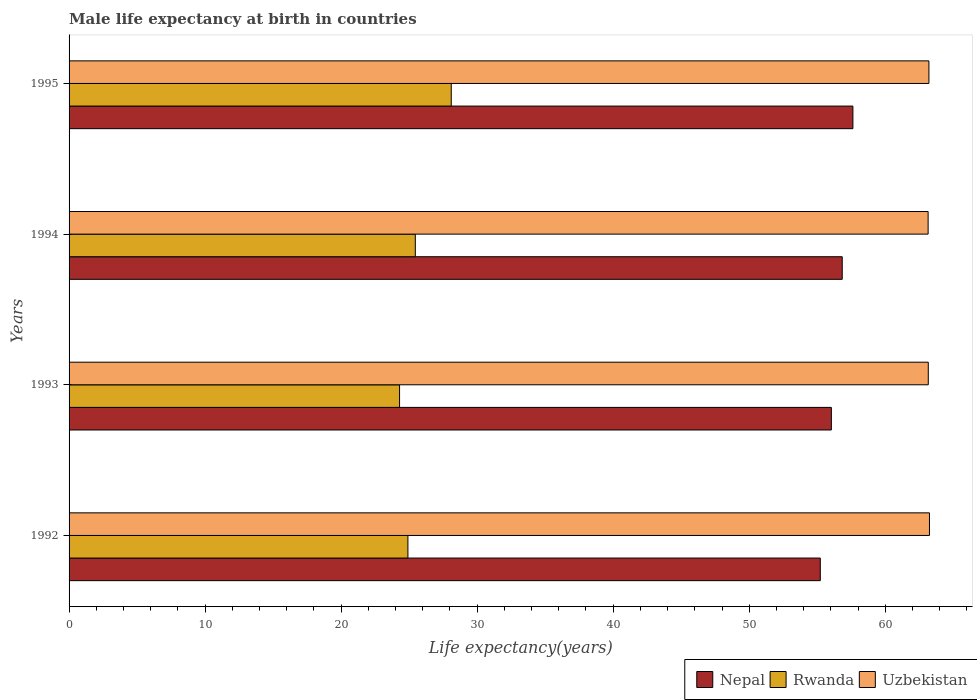Are the number of bars per tick equal to the number of legend labels?
Provide a succinct answer. Yes. In how many cases, is the number of bars for a given year not equal to the number of legend labels?
Provide a short and direct response. 0. What is the male life expectancy at birth in Uzbekistan in 1995?
Ensure brevity in your answer.  63.21. Across all years, what is the maximum male life expectancy at birth in Rwanda?
Your answer should be compact. 28.09. Across all years, what is the minimum male life expectancy at birth in Uzbekistan?
Provide a succinct answer. 63.15. In which year was the male life expectancy at birth in Nepal maximum?
Offer a terse response. 1995. What is the total male life expectancy at birth in Nepal in the graph?
Offer a terse response. 225.72. What is the difference between the male life expectancy at birth in Nepal in 1992 and that in 1995?
Offer a very short reply. -2.4. What is the difference between the male life expectancy at birth in Uzbekistan in 1993 and the male life expectancy at birth in Rwanda in 1992?
Provide a succinct answer. 38.25. What is the average male life expectancy at birth in Rwanda per year?
Make the answer very short. 25.69. In the year 1995, what is the difference between the male life expectancy at birth in Nepal and male life expectancy at birth in Rwanda?
Your answer should be very brief. 29.53. In how many years, is the male life expectancy at birth in Nepal greater than 26 years?
Give a very brief answer. 4. What is the ratio of the male life expectancy at birth in Rwanda in 1992 to that in 1994?
Your response must be concise. 0.98. What is the difference between the highest and the second highest male life expectancy at birth in Rwanda?
Your answer should be compact. 2.64. What is the difference between the highest and the lowest male life expectancy at birth in Nepal?
Your answer should be very brief. 2.4. In how many years, is the male life expectancy at birth in Rwanda greater than the average male life expectancy at birth in Rwanda taken over all years?
Provide a succinct answer. 1. What does the 2nd bar from the top in 1995 represents?
Provide a succinct answer. Rwanda. What does the 3rd bar from the bottom in 1992 represents?
Your response must be concise. Uzbekistan. How many bars are there?
Offer a terse response. 12. Are all the bars in the graph horizontal?
Your answer should be compact. Yes. How many years are there in the graph?
Offer a terse response. 4. What is the difference between two consecutive major ticks on the X-axis?
Your answer should be compact. 10. Are the values on the major ticks of X-axis written in scientific E-notation?
Provide a succinct answer. No. Does the graph contain any zero values?
Keep it short and to the point. No. Does the graph contain grids?
Offer a terse response. No. How many legend labels are there?
Your response must be concise. 3. What is the title of the graph?
Ensure brevity in your answer.  Male life expectancy at birth in countries. Does "Bahamas" appear as one of the legend labels in the graph?
Give a very brief answer. No. What is the label or title of the X-axis?
Make the answer very short. Life expectancy(years). What is the Life expectancy(years) of Nepal in 1992?
Your answer should be compact. 55.22. What is the Life expectancy(years) in Rwanda in 1992?
Provide a short and direct response. 24.91. What is the Life expectancy(years) of Uzbekistan in 1992?
Your answer should be very brief. 63.25. What is the Life expectancy(years) of Nepal in 1993?
Provide a short and direct response. 56.04. What is the Life expectancy(years) of Rwanda in 1993?
Keep it short and to the point. 24.3. What is the Life expectancy(years) in Uzbekistan in 1993?
Ensure brevity in your answer.  63.16. What is the Life expectancy(years) of Nepal in 1994?
Give a very brief answer. 56.84. What is the Life expectancy(years) of Rwanda in 1994?
Offer a terse response. 25.45. What is the Life expectancy(years) in Uzbekistan in 1994?
Keep it short and to the point. 63.15. What is the Life expectancy(years) of Nepal in 1995?
Your response must be concise. 57.62. What is the Life expectancy(years) of Rwanda in 1995?
Provide a short and direct response. 28.09. What is the Life expectancy(years) in Uzbekistan in 1995?
Provide a short and direct response. 63.21. Across all years, what is the maximum Life expectancy(years) in Nepal?
Offer a very short reply. 57.62. Across all years, what is the maximum Life expectancy(years) of Rwanda?
Offer a very short reply. 28.09. Across all years, what is the maximum Life expectancy(years) in Uzbekistan?
Provide a short and direct response. 63.25. Across all years, what is the minimum Life expectancy(years) of Nepal?
Give a very brief answer. 55.22. Across all years, what is the minimum Life expectancy(years) of Rwanda?
Provide a succinct answer. 24.3. Across all years, what is the minimum Life expectancy(years) in Uzbekistan?
Your answer should be very brief. 63.15. What is the total Life expectancy(years) in Nepal in the graph?
Your response must be concise. 225.72. What is the total Life expectancy(years) in Rwanda in the graph?
Make the answer very short. 102.75. What is the total Life expectancy(years) in Uzbekistan in the graph?
Your answer should be very brief. 252.77. What is the difference between the Life expectancy(years) of Nepal in 1992 and that in 1993?
Offer a very short reply. -0.81. What is the difference between the Life expectancy(years) of Rwanda in 1992 and that in 1993?
Your answer should be compact. 0.61. What is the difference between the Life expectancy(years) of Uzbekistan in 1992 and that in 1993?
Ensure brevity in your answer.  0.09. What is the difference between the Life expectancy(years) in Nepal in 1992 and that in 1994?
Give a very brief answer. -1.61. What is the difference between the Life expectancy(years) in Rwanda in 1992 and that in 1994?
Provide a succinct answer. -0.54. What is the difference between the Life expectancy(years) of Uzbekistan in 1992 and that in 1994?
Provide a short and direct response. 0.1. What is the difference between the Life expectancy(years) of Nepal in 1992 and that in 1995?
Ensure brevity in your answer.  -2.4. What is the difference between the Life expectancy(years) of Rwanda in 1992 and that in 1995?
Keep it short and to the point. -3.19. What is the difference between the Life expectancy(years) in Nepal in 1993 and that in 1994?
Your response must be concise. -0.8. What is the difference between the Life expectancy(years) of Rwanda in 1993 and that in 1994?
Keep it short and to the point. -1.16. What is the difference between the Life expectancy(years) of Uzbekistan in 1993 and that in 1994?
Keep it short and to the point. 0.01. What is the difference between the Life expectancy(years) in Nepal in 1993 and that in 1995?
Your response must be concise. -1.58. What is the difference between the Life expectancy(years) in Uzbekistan in 1993 and that in 1995?
Provide a short and direct response. -0.05. What is the difference between the Life expectancy(years) in Nepal in 1994 and that in 1995?
Make the answer very short. -0.78. What is the difference between the Life expectancy(years) of Rwanda in 1994 and that in 1995?
Offer a very short reply. -2.64. What is the difference between the Life expectancy(years) in Uzbekistan in 1994 and that in 1995?
Offer a very short reply. -0.06. What is the difference between the Life expectancy(years) of Nepal in 1992 and the Life expectancy(years) of Rwanda in 1993?
Provide a succinct answer. 30.93. What is the difference between the Life expectancy(years) of Nepal in 1992 and the Life expectancy(years) of Uzbekistan in 1993?
Offer a terse response. -7.94. What is the difference between the Life expectancy(years) in Rwanda in 1992 and the Life expectancy(years) in Uzbekistan in 1993?
Keep it short and to the point. -38.25. What is the difference between the Life expectancy(years) of Nepal in 1992 and the Life expectancy(years) of Rwanda in 1994?
Offer a terse response. 29.77. What is the difference between the Life expectancy(years) in Nepal in 1992 and the Life expectancy(years) in Uzbekistan in 1994?
Your response must be concise. -7.93. What is the difference between the Life expectancy(years) of Rwanda in 1992 and the Life expectancy(years) of Uzbekistan in 1994?
Offer a very short reply. -38.24. What is the difference between the Life expectancy(years) of Nepal in 1992 and the Life expectancy(years) of Rwanda in 1995?
Offer a terse response. 27.13. What is the difference between the Life expectancy(years) of Nepal in 1992 and the Life expectancy(years) of Uzbekistan in 1995?
Your response must be concise. -7.99. What is the difference between the Life expectancy(years) of Rwanda in 1992 and the Life expectancy(years) of Uzbekistan in 1995?
Your response must be concise. -38.3. What is the difference between the Life expectancy(years) of Nepal in 1993 and the Life expectancy(years) of Rwanda in 1994?
Give a very brief answer. 30.58. What is the difference between the Life expectancy(years) of Nepal in 1993 and the Life expectancy(years) of Uzbekistan in 1994?
Ensure brevity in your answer.  -7.11. What is the difference between the Life expectancy(years) of Rwanda in 1993 and the Life expectancy(years) of Uzbekistan in 1994?
Your response must be concise. -38.86. What is the difference between the Life expectancy(years) in Nepal in 1993 and the Life expectancy(years) in Rwanda in 1995?
Give a very brief answer. 27.94. What is the difference between the Life expectancy(years) of Nepal in 1993 and the Life expectancy(years) of Uzbekistan in 1995?
Your answer should be compact. -7.17. What is the difference between the Life expectancy(years) in Rwanda in 1993 and the Life expectancy(years) in Uzbekistan in 1995?
Your answer should be compact. -38.91. What is the difference between the Life expectancy(years) in Nepal in 1994 and the Life expectancy(years) in Rwanda in 1995?
Give a very brief answer. 28.74. What is the difference between the Life expectancy(years) of Nepal in 1994 and the Life expectancy(years) of Uzbekistan in 1995?
Keep it short and to the point. -6.37. What is the difference between the Life expectancy(years) in Rwanda in 1994 and the Life expectancy(years) in Uzbekistan in 1995?
Provide a succinct answer. -37.76. What is the average Life expectancy(years) of Nepal per year?
Offer a terse response. 56.43. What is the average Life expectancy(years) of Rwanda per year?
Provide a succinct answer. 25.69. What is the average Life expectancy(years) in Uzbekistan per year?
Make the answer very short. 63.19. In the year 1992, what is the difference between the Life expectancy(years) of Nepal and Life expectancy(years) of Rwanda?
Make the answer very short. 30.31. In the year 1992, what is the difference between the Life expectancy(years) of Nepal and Life expectancy(years) of Uzbekistan?
Ensure brevity in your answer.  -8.03. In the year 1992, what is the difference between the Life expectancy(years) of Rwanda and Life expectancy(years) of Uzbekistan?
Keep it short and to the point. -38.34. In the year 1993, what is the difference between the Life expectancy(years) of Nepal and Life expectancy(years) of Rwanda?
Offer a terse response. 31.74. In the year 1993, what is the difference between the Life expectancy(years) of Nepal and Life expectancy(years) of Uzbekistan?
Provide a succinct answer. -7.13. In the year 1993, what is the difference between the Life expectancy(years) in Rwanda and Life expectancy(years) in Uzbekistan?
Ensure brevity in your answer.  -38.87. In the year 1994, what is the difference between the Life expectancy(years) in Nepal and Life expectancy(years) in Rwanda?
Offer a very short reply. 31.38. In the year 1994, what is the difference between the Life expectancy(years) of Nepal and Life expectancy(years) of Uzbekistan?
Your response must be concise. -6.31. In the year 1994, what is the difference between the Life expectancy(years) in Rwanda and Life expectancy(years) in Uzbekistan?
Your response must be concise. -37.7. In the year 1995, what is the difference between the Life expectancy(years) of Nepal and Life expectancy(years) of Rwanda?
Your answer should be very brief. 29.53. In the year 1995, what is the difference between the Life expectancy(years) of Nepal and Life expectancy(years) of Uzbekistan?
Offer a very short reply. -5.59. In the year 1995, what is the difference between the Life expectancy(years) of Rwanda and Life expectancy(years) of Uzbekistan?
Offer a terse response. -35.12. What is the ratio of the Life expectancy(years) in Nepal in 1992 to that in 1993?
Keep it short and to the point. 0.99. What is the ratio of the Life expectancy(years) of Rwanda in 1992 to that in 1993?
Give a very brief answer. 1.03. What is the ratio of the Life expectancy(years) in Nepal in 1992 to that in 1994?
Ensure brevity in your answer.  0.97. What is the ratio of the Life expectancy(years) of Rwanda in 1992 to that in 1994?
Offer a terse response. 0.98. What is the ratio of the Life expectancy(years) in Uzbekistan in 1992 to that in 1994?
Ensure brevity in your answer.  1. What is the ratio of the Life expectancy(years) in Nepal in 1992 to that in 1995?
Your answer should be compact. 0.96. What is the ratio of the Life expectancy(years) of Rwanda in 1992 to that in 1995?
Make the answer very short. 0.89. What is the ratio of the Life expectancy(years) of Nepal in 1993 to that in 1994?
Your response must be concise. 0.99. What is the ratio of the Life expectancy(years) in Rwanda in 1993 to that in 1994?
Make the answer very short. 0.95. What is the ratio of the Life expectancy(years) in Uzbekistan in 1993 to that in 1994?
Your answer should be compact. 1. What is the ratio of the Life expectancy(years) of Nepal in 1993 to that in 1995?
Make the answer very short. 0.97. What is the ratio of the Life expectancy(years) of Rwanda in 1993 to that in 1995?
Offer a terse response. 0.86. What is the ratio of the Life expectancy(years) in Uzbekistan in 1993 to that in 1995?
Make the answer very short. 1. What is the ratio of the Life expectancy(years) of Nepal in 1994 to that in 1995?
Your response must be concise. 0.99. What is the ratio of the Life expectancy(years) in Rwanda in 1994 to that in 1995?
Give a very brief answer. 0.91. What is the ratio of the Life expectancy(years) of Uzbekistan in 1994 to that in 1995?
Ensure brevity in your answer.  1. What is the difference between the highest and the second highest Life expectancy(years) in Nepal?
Offer a terse response. 0.78. What is the difference between the highest and the second highest Life expectancy(years) of Rwanda?
Ensure brevity in your answer.  2.64. What is the difference between the highest and the second highest Life expectancy(years) of Uzbekistan?
Give a very brief answer. 0.04. What is the difference between the highest and the lowest Life expectancy(years) in Nepal?
Make the answer very short. 2.4. What is the difference between the highest and the lowest Life expectancy(years) in Uzbekistan?
Provide a short and direct response. 0.1. 